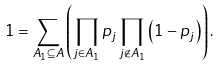<formula> <loc_0><loc_0><loc_500><loc_500>1 = \sum _ { A _ { 1 } \subseteq A } \left ( \prod _ { j \in A _ { 1 } } p _ { j } \prod _ { j \notin A _ { 1 } } \left ( 1 - p _ { j } \right ) \right ) .</formula> 